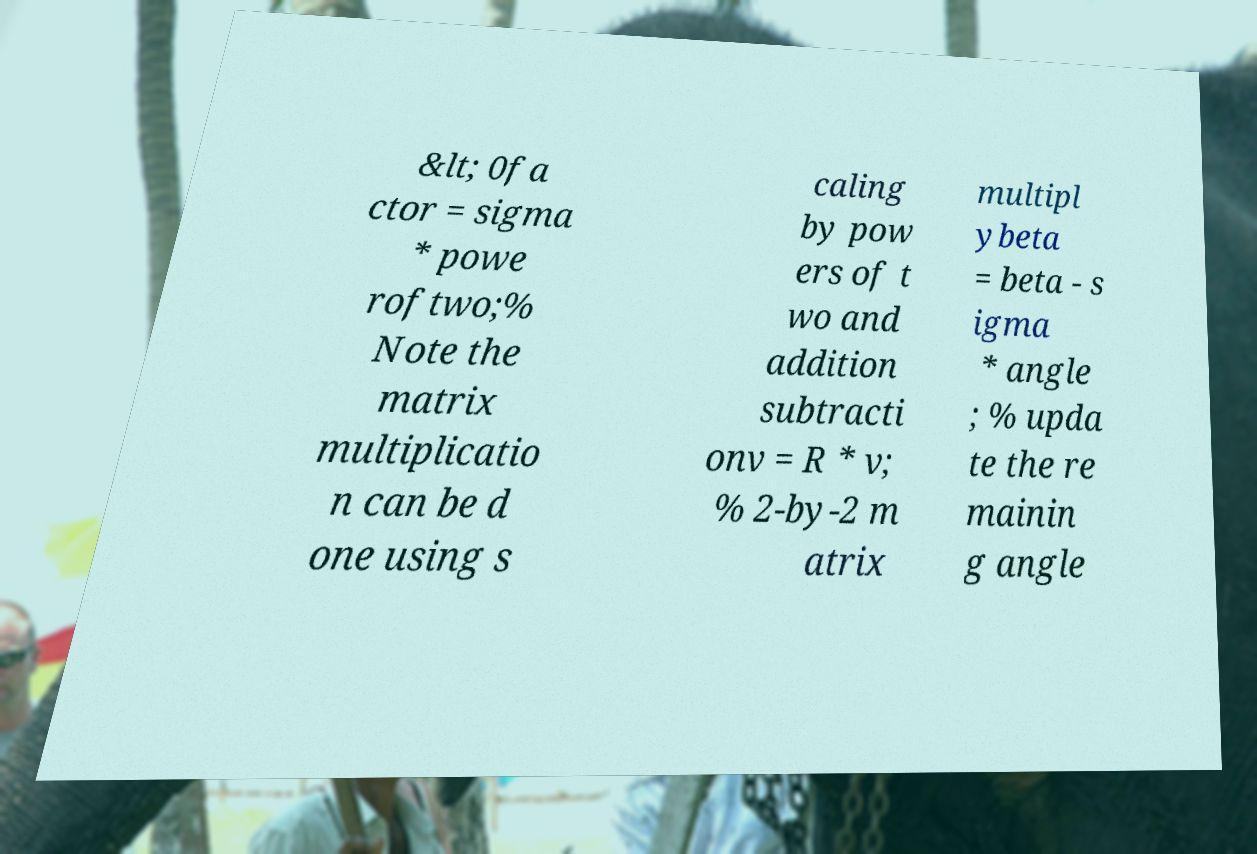Can you accurately transcribe the text from the provided image for me? &lt; 0fa ctor = sigma * powe roftwo;% Note the matrix multiplicatio n can be d one using s caling by pow ers of t wo and addition subtracti onv = R * v; % 2-by-2 m atrix multipl ybeta = beta - s igma * angle ; % upda te the re mainin g angle 